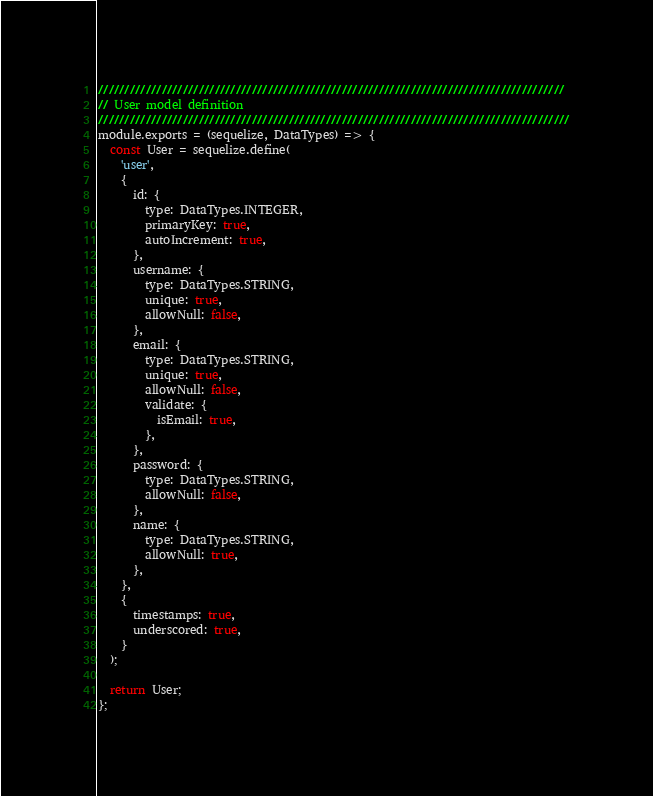<code> <loc_0><loc_0><loc_500><loc_500><_JavaScript_>////////////////////////////////////////////////////////////////////////////////////////
// User model definition
/////////////////////////////////////////////////////////////////////////////////////////
module.exports = (sequelize, DataTypes) => {
  const User = sequelize.define(
    'user',
    {
      id: {
        type: DataTypes.INTEGER,
        primaryKey: true,
        autoIncrement: true,
      },
      username: {
        type: DataTypes.STRING,
        unique: true,
        allowNull: false,
      },
      email: {
        type: DataTypes.STRING,
        unique: true,
        allowNull: false,
        validate: {
          isEmail: true,
        },
      },
      password: {
        type: DataTypes.STRING,
        allowNull: false,
      },
      name: {
        type: DataTypes.STRING,
        allowNull: true,
      },
    },
    {
      timestamps: true,
      underscored: true,
    }
  );

  return User;
};
</code> 